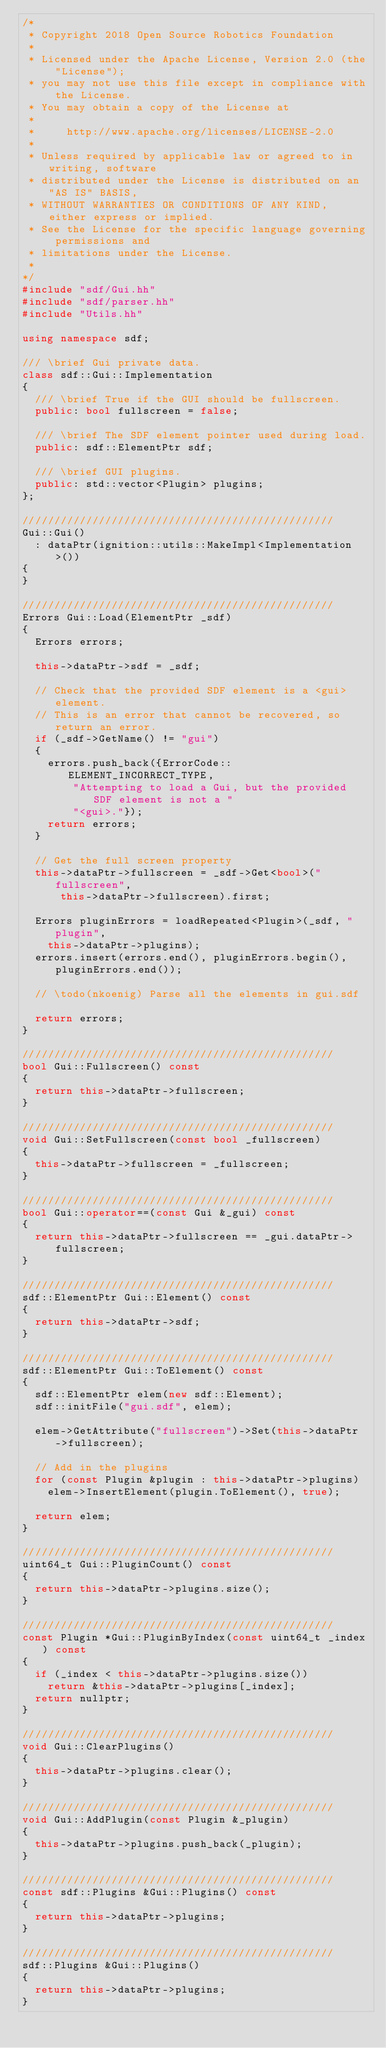<code> <loc_0><loc_0><loc_500><loc_500><_C++_>/*
 * Copyright 2018 Open Source Robotics Foundation
 *
 * Licensed under the Apache License, Version 2.0 (the "License");
 * you may not use this file except in compliance with the License.
 * You may obtain a copy of the License at
 *
 *     http://www.apache.org/licenses/LICENSE-2.0
 *
 * Unless required by applicable law or agreed to in writing, software
 * distributed under the License is distributed on an "AS IS" BASIS,
 * WITHOUT WARRANTIES OR CONDITIONS OF ANY KIND, either express or implied.
 * See the License for the specific language governing permissions and
 * limitations under the License.
 *
*/
#include "sdf/Gui.hh"
#include "sdf/parser.hh"
#include "Utils.hh"

using namespace sdf;

/// \brief Gui private data.
class sdf::Gui::Implementation
{
  /// \brief True if the GUI should be fullscreen.
  public: bool fullscreen = false;

  /// \brief The SDF element pointer used during load.
  public: sdf::ElementPtr sdf;

  /// \brief GUI plugins.
  public: std::vector<Plugin> plugins;
};

/////////////////////////////////////////////////
Gui::Gui()
  : dataPtr(ignition::utils::MakeImpl<Implementation>())
{
}

/////////////////////////////////////////////////
Errors Gui::Load(ElementPtr _sdf)
{
  Errors errors;

  this->dataPtr->sdf = _sdf;

  // Check that the provided SDF element is a <gui> element.
  // This is an error that cannot be recovered, so return an error.
  if (_sdf->GetName() != "gui")
  {
    errors.push_back({ErrorCode::ELEMENT_INCORRECT_TYPE,
        "Attempting to load a Gui, but the provided SDF element is not a "
        "<gui>."});
    return errors;
  }

  // Get the full screen property
  this->dataPtr->fullscreen = _sdf->Get<bool>("fullscreen",
      this->dataPtr->fullscreen).first;

  Errors pluginErrors = loadRepeated<Plugin>(_sdf, "plugin",
    this->dataPtr->plugins);
  errors.insert(errors.end(), pluginErrors.begin(), pluginErrors.end());

  // \todo(nkoenig) Parse all the elements in gui.sdf

  return errors;
}

/////////////////////////////////////////////////
bool Gui::Fullscreen() const
{
  return this->dataPtr->fullscreen;
}

/////////////////////////////////////////////////
void Gui::SetFullscreen(const bool _fullscreen)
{
  this->dataPtr->fullscreen = _fullscreen;
}

/////////////////////////////////////////////////
bool Gui::operator==(const Gui &_gui) const
{
  return this->dataPtr->fullscreen == _gui.dataPtr->fullscreen;
}

/////////////////////////////////////////////////
sdf::ElementPtr Gui::Element() const
{
  return this->dataPtr->sdf;
}

/////////////////////////////////////////////////
sdf::ElementPtr Gui::ToElement() const
{
  sdf::ElementPtr elem(new sdf::Element);
  sdf::initFile("gui.sdf", elem);

  elem->GetAttribute("fullscreen")->Set(this->dataPtr->fullscreen);

  // Add in the plugins
  for (const Plugin &plugin : this->dataPtr->plugins)
    elem->InsertElement(plugin.ToElement(), true);

  return elem;
}

/////////////////////////////////////////////////
uint64_t Gui::PluginCount() const
{
  return this->dataPtr->plugins.size();
}

/////////////////////////////////////////////////
const Plugin *Gui::PluginByIndex(const uint64_t _index) const
{
  if (_index < this->dataPtr->plugins.size())
    return &this->dataPtr->plugins[_index];
  return nullptr;
}

/////////////////////////////////////////////////
void Gui::ClearPlugins()
{
  this->dataPtr->plugins.clear();
}

/////////////////////////////////////////////////
void Gui::AddPlugin(const Plugin &_plugin)
{
  this->dataPtr->plugins.push_back(_plugin);
}

/////////////////////////////////////////////////
const sdf::Plugins &Gui::Plugins() const
{
  return this->dataPtr->plugins;
}

/////////////////////////////////////////////////
sdf::Plugins &Gui::Plugins()
{
  return this->dataPtr->plugins;
}


</code> 